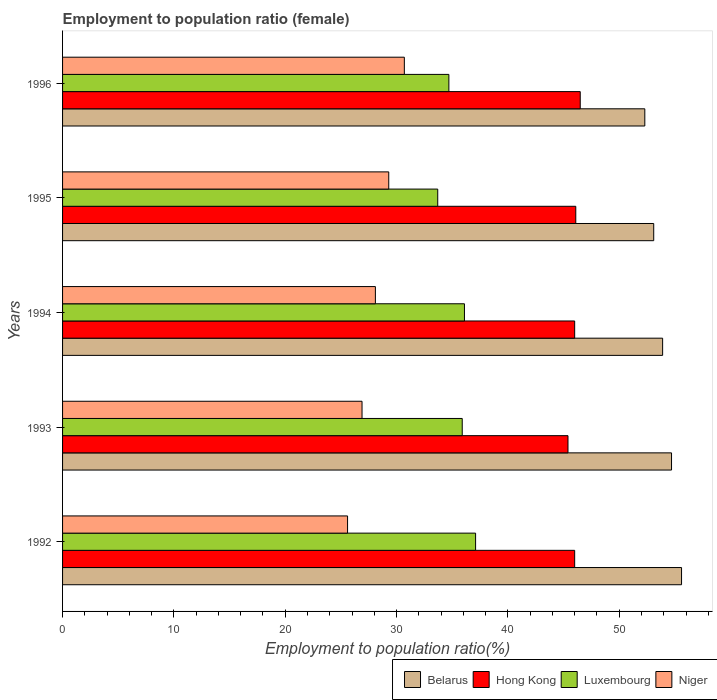Are the number of bars on each tick of the Y-axis equal?
Your answer should be compact. Yes. How many bars are there on the 4th tick from the top?
Offer a terse response. 4. How many bars are there on the 3rd tick from the bottom?
Provide a succinct answer. 4. What is the label of the 5th group of bars from the top?
Provide a succinct answer. 1992. In how many cases, is the number of bars for a given year not equal to the number of legend labels?
Give a very brief answer. 0. What is the employment to population ratio in Niger in 1996?
Your response must be concise. 30.7. Across all years, what is the maximum employment to population ratio in Hong Kong?
Make the answer very short. 46.5. Across all years, what is the minimum employment to population ratio in Belarus?
Make the answer very short. 52.3. What is the total employment to population ratio in Hong Kong in the graph?
Provide a succinct answer. 230. What is the difference between the employment to population ratio in Niger in 1992 and that in 1995?
Your answer should be very brief. -3.7. What is the difference between the employment to population ratio in Hong Kong in 1992 and the employment to population ratio in Belarus in 1996?
Offer a terse response. -6.3. What is the average employment to population ratio in Niger per year?
Provide a short and direct response. 28.12. In the year 1992, what is the difference between the employment to population ratio in Luxembourg and employment to population ratio in Belarus?
Your answer should be compact. -18.5. In how many years, is the employment to population ratio in Niger greater than 30 %?
Ensure brevity in your answer.  1. What is the ratio of the employment to population ratio in Luxembourg in 1993 to that in 1996?
Provide a short and direct response. 1.03. Is the difference between the employment to population ratio in Luxembourg in 1994 and 1996 greater than the difference between the employment to population ratio in Belarus in 1994 and 1996?
Provide a succinct answer. No. What is the difference between the highest and the second highest employment to population ratio in Niger?
Provide a short and direct response. 1.4. What is the difference between the highest and the lowest employment to population ratio in Hong Kong?
Ensure brevity in your answer.  1.1. In how many years, is the employment to population ratio in Hong Kong greater than the average employment to population ratio in Hong Kong taken over all years?
Ensure brevity in your answer.  2. Is the sum of the employment to population ratio in Luxembourg in 1992 and 1993 greater than the maximum employment to population ratio in Belarus across all years?
Provide a short and direct response. Yes. Is it the case that in every year, the sum of the employment to population ratio in Hong Kong and employment to population ratio in Luxembourg is greater than the sum of employment to population ratio in Niger and employment to population ratio in Belarus?
Make the answer very short. No. What does the 4th bar from the top in 1995 represents?
Provide a short and direct response. Belarus. What does the 4th bar from the bottom in 1993 represents?
Your answer should be compact. Niger. How many bars are there?
Offer a terse response. 20. How many years are there in the graph?
Ensure brevity in your answer.  5. Are the values on the major ticks of X-axis written in scientific E-notation?
Your response must be concise. No. Does the graph contain grids?
Your answer should be compact. No. How many legend labels are there?
Ensure brevity in your answer.  4. What is the title of the graph?
Make the answer very short. Employment to population ratio (female). Does "Liechtenstein" appear as one of the legend labels in the graph?
Offer a terse response. No. What is the label or title of the Y-axis?
Your answer should be very brief. Years. What is the Employment to population ratio(%) in Belarus in 1992?
Your response must be concise. 55.6. What is the Employment to population ratio(%) in Hong Kong in 1992?
Provide a succinct answer. 46. What is the Employment to population ratio(%) in Luxembourg in 1992?
Your response must be concise. 37.1. What is the Employment to population ratio(%) in Niger in 1992?
Keep it short and to the point. 25.6. What is the Employment to population ratio(%) of Belarus in 1993?
Provide a short and direct response. 54.7. What is the Employment to population ratio(%) of Hong Kong in 1993?
Make the answer very short. 45.4. What is the Employment to population ratio(%) of Luxembourg in 1993?
Keep it short and to the point. 35.9. What is the Employment to population ratio(%) in Niger in 1993?
Your answer should be very brief. 26.9. What is the Employment to population ratio(%) in Belarus in 1994?
Provide a short and direct response. 53.9. What is the Employment to population ratio(%) of Luxembourg in 1994?
Provide a short and direct response. 36.1. What is the Employment to population ratio(%) of Niger in 1994?
Your answer should be very brief. 28.1. What is the Employment to population ratio(%) in Belarus in 1995?
Provide a short and direct response. 53.1. What is the Employment to population ratio(%) in Hong Kong in 1995?
Your response must be concise. 46.1. What is the Employment to population ratio(%) of Luxembourg in 1995?
Give a very brief answer. 33.7. What is the Employment to population ratio(%) in Niger in 1995?
Offer a very short reply. 29.3. What is the Employment to population ratio(%) in Belarus in 1996?
Your response must be concise. 52.3. What is the Employment to population ratio(%) in Hong Kong in 1996?
Offer a very short reply. 46.5. What is the Employment to population ratio(%) of Luxembourg in 1996?
Provide a short and direct response. 34.7. What is the Employment to population ratio(%) in Niger in 1996?
Ensure brevity in your answer.  30.7. Across all years, what is the maximum Employment to population ratio(%) of Belarus?
Keep it short and to the point. 55.6. Across all years, what is the maximum Employment to population ratio(%) of Hong Kong?
Your answer should be compact. 46.5. Across all years, what is the maximum Employment to population ratio(%) of Luxembourg?
Provide a succinct answer. 37.1. Across all years, what is the maximum Employment to population ratio(%) of Niger?
Offer a terse response. 30.7. Across all years, what is the minimum Employment to population ratio(%) in Belarus?
Provide a short and direct response. 52.3. Across all years, what is the minimum Employment to population ratio(%) in Hong Kong?
Offer a very short reply. 45.4. Across all years, what is the minimum Employment to population ratio(%) of Luxembourg?
Your response must be concise. 33.7. Across all years, what is the minimum Employment to population ratio(%) of Niger?
Offer a very short reply. 25.6. What is the total Employment to population ratio(%) of Belarus in the graph?
Offer a very short reply. 269.6. What is the total Employment to population ratio(%) of Hong Kong in the graph?
Give a very brief answer. 230. What is the total Employment to population ratio(%) in Luxembourg in the graph?
Make the answer very short. 177.5. What is the total Employment to population ratio(%) in Niger in the graph?
Your answer should be compact. 140.6. What is the difference between the Employment to population ratio(%) in Hong Kong in 1992 and that in 1993?
Provide a short and direct response. 0.6. What is the difference between the Employment to population ratio(%) of Niger in 1992 and that in 1993?
Provide a succinct answer. -1.3. What is the difference between the Employment to population ratio(%) in Belarus in 1992 and that in 1994?
Offer a very short reply. 1.7. What is the difference between the Employment to population ratio(%) in Hong Kong in 1992 and that in 1994?
Ensure brevity in your answer.  0. What is the difference between the Employment to population ratio(%) in Belarus in 1992 and that in 1995?
Provide a succinct answer. 2.5. What is the difference between the Employment to population ratio(%) of Hong Kong in 1992 and that in 1995?
Keep it short and to the point. -0.1. What is the difference between the Employment to population ratio(%) in Niger in 1992 and that in 1995?
Give a very brief answer. -3.7. What is the difference between the Employment to population ratio(%) in Belarus in 1992 and that in 1996?
Provide a short and direct response. 3.3. What is the difference between the Employment to population ratio(%) of Niger in 1992 and that in 1996?
Your response must be concise. -5.1. What is the difference between the Employment to population ratio(%) in Hong Kong in 1993 and that in 1994?
Offer a terse response. -0.6. What is the difference between the Employment to population ratio(%) of Luxembourg in 1993 and that in 1994?
Offer a terse response. -0.2. What is the difference between the Employment to population ratio(%) of Belarus in 1993 and that in 1995?
Keep it short and to the point. 1.6. What is the difference between the Employment to population ratio(%) of Belarus in 1993 and that in 1996?
Provide a short and direct response. 2.4. What is the difference between the Employment to population ratio(%) in Hong Kong in 1993 and that in 1996?
Provide a succinct answer. -1.1. What is the difference between the Employment to population ratio(%) of Luxembourg in 1993 and that in 1996?
Your response must be concise. 1.2. What is the difference between the Employment to population ratio(%) in Niger in 1993 and that in 1996?
Provide a short and direct response. -3.8. What is the difference between the Employment to population ratio(%) of Hong Kong in 1994 and that in 1995?
Keep it short and to the point. -0.1. What is the difference between the Employment to population ratio(%) of Luxembourg in 1994 and that in 1995?
Provide a short and direct response. 2.4. What is the difference between the Employment to population ratio(%) of Luxembourg in 1994 and that in 1996?
Provide a short and direct response. 1.4. What is the difference between the Employment to population ratio(%) of Niger in 1994 and that in 1996?
Ensure brevity in your answer.  -2.6. What is the difference between the Employment to population ratio(%) in Niger in 1995 and that in 1996?
Your response must be concise. -1.4. What is the difference between the Employment to population ratio(%) in Belarus in 1992 and the Employment to population ratio(%) in Luxembourg in 1993?
Your response must be concise. 19.7. What is the difference between the Employment to population ratio(%) in Belarus in 1992 and the Employment to population ratio(%) in Niger in 1993?
Give a very brief answer. 28.7. What is the difference between the Employment to population ratio(%) of Hong Kong in 1992 and the Employment to population ratio(%) of Luxembourg in 1993?
Ensure brevity in your answer.  10.1. What is the difference between the Employment to population ratio(%) in Luxembourg in 1992 and the Employment to population ratio(%) in Niger in 1994?
Offer a terse response. 9. What is the difference between the Employment to population ratio(%) in Belarus in 1992 and the Employment to population ratio(%) in Hong Kong in 1995?
Offer a very short reply. 9.5. What is the difference between the Employment to population ratio(%) of Belarus in 1992 and the Employment to population ratio(%) of Luxembourg in 1995?
Ensure brevity in your answer.  21.9. What is the difference between the Employment to population ratio(%) of Belarus in 1992 and the Employment to population ratio(%) of Niger in 1995?
Ensure brevity in your answer.  26.3. What is the difference between the Employment to population ratio(%) in Hong Kong in 1992 and the Employment to population ratio(%) in Luxembourg in 1995?
Provide a short and direct response. 12.3. What is the difference between the Employment to population ratio(%) in Hong Kong in 1992 and the Employment to population ratio(%) in Niger in 1995?
Ensure brevity in your answer.  16.7. What is the difference between the Employment to population ratio(%) of Belarus in 1992 and the Employment to population ratio(%) of Hong Kong in 1996?
Your response must be concise. 9.1. What is the difference between the Employment to population ratio(%) of Belarus in 1992 and the Employment to population ratio(%) of Luxembourg in 1996?
Ensure brevity in your answer.  20.9. What is the difference between the Employment to population ratio(%) in Belarus in 1992 and the Employment to population ratio(%) in Niger in 1996?
Make the answer very short. 24.9. What is the difference between the Employment to population ratio(%) of Hong Kong in 1992 and the Employment to population ratio(%) of Luxembourg in 1996?
Ensure brevity in your answer.  11.3. What is the difference between the Employment to population ratio(%) in Luxembourg in 1992 and the Employment to population ratio(%) in Niger in 1996?
Make the answer very short. 6.4. What is the difference between the Employment to population ratio(%) in Belarus in 1993 and the Employment to population ratio(%) in Hong Kong in 1994?
Provide a succinct answer. 8.7. What is the difference between the Employment to population ratio(%) in Belarus in 1993 and the Employment to population ratio(%) in Luxembourg in 1994?
Your answer should be compact. 18.6. What is the difference between the Employment to population ratio(%) in Belarus in 1993 and the Employment to population ratio(%) in Niger in 1994?
Keep it short and to the point. 26.6. What is the difference between the Employment to population ratio(%) in Hong Kong in 1993 and the Employment to population ratio(%) in Luxembourg in 1994?
Make the answer very short. 9.3. What is the difference between the Employment to population ratio(%) of Belarus in 1993 and the Employment to population ratio(%) of Niger in 1995?
Provide a short and direct response. 25.4. What is the difference between the Employment to population ratio(%) of Hong Kong in 1993 and the Employment to population ratio(%) of Luxembourg in 1995?
Provide a succinct answer. 11.7. What is the difference between the Employment to population ratio(%) in Luxembourg in 1993 and the Employment to population ratio(%) in Niger in 1995?
Make the answer very short. 6.6. What is the difference between the Employment to population ratio(%) of Belarus in 1993 and the Employment to population ratio(%) of Luxembourg in 1996?
Offer a terse response. 20. What is the difference between the Employment to population ratio(%) of Hong Kong in 1993 and the Employment to population ratio(%) of Luxembourg in 1996?
Provide a succinct answer. 10.7. What is the difference between the Employment to population ratio(%) in Luxembourg in 1993 and the Employment to population ratio(%) in Niger in 1996?
Your response must be concise. 5.2. What is the difference between the Employment to population ratio(%) in Belarus in 1994 and the Employment to population ratio(%) in Luxembourg in 1995?
Offer a terse response. 20.2. What is the difference between the Employment to population ratio(%) in Belarus in 1994 and the Employment to population ratio(%) in Niger in 1995?
Your answer should be compact. 24.6. What is the difference between the Employment to population ratio(%) of Hong Kong in 1994 and the Employment to population ratio(%) of Niger in 1995?
Make the answer very short. 16.7. What is the difference between the Employment to population ratio(%) in Belarus in 1994 and the Employment to population ratio(%) in Hong Kong in 1996?
Give a very brief answer. 7.4. What is the difference between the Employment to population ratio(%) in Belarus in 1994 and the Employment to population ratio(%) in Luxembourg in 1996?
Provide a short and direct response. 19.2. What is the difference between the Employment to population ratio(%) of Belarus in 1994 and the Employment to population ratio(%) of Niger in 1996?
Your answer should be compact. 23.2. What is the difference between the Employment to population ratio(%) of Hong Kong in 1994 and the Employment to population ratio(%) of Luxembourg in 1996?
Keep it short and to the point. 11.3. What is the difference between the Employment to population ratio(%) of Belarus in 1995 and the Employment to population ratio(%) of Luxembourg in 1996?
Your response must be concise. 18.4. What is the difference between the Employment to population ratio(%) in Belarus in 1995 and the Employment to population ratio(%) in Niger in 1996?
Make the answer very short. 22.4. What is the difference between the Employment to population ratio(%) of Hong Kong in 1995 and the Employment to population ratio(%) of Luxembourg in 1996?
Keep it short and to the point. 11.4. What is the difference between the Employment to population ratio(%) in Hong Kong in 1995 and the Employment to population ratio(%) in Niger in 1996?
Give a very brief answer. 15.4. What is the average Employment to population ratio(%) in Belarus per year?
Make the answer very short. 53.92. What is the average Employment to population ratio(%) in Hong Kong per year?
Offer a very short reply. 46. What is the average Employment to population ratio(%) in Luxembourg per year?
Ensure brevity in your answer.  35.5. What is the average Employment to population ratio(%) in Niger per year?
Provide a short and direct response. 28.12. In the year 1992, what is the difference between the Employment to population ratio(%) in Belarus and Employment to population ratio(%) in Luxembourg?
Make the answer very short. 18.5. In the year 1992, what is the difference between the Employment to population ratio(%) of Hong Kong and Employment to population ratio(%) of Niger?
Your response must be concise. 20.4. In the year 1993, what is the difference between the Employment to population ratio(%) in Belarus and Employment to population ratio(%) in Hong Kong?
Your answer should be very brief. 9.3. In the year 1993, what is the difference between the Employment to population ratio(%) of Belarus and Employment to population ratio(%) of Niger?
Offer a terse response. 27.8. In the year 1993, what is the difference between the Employment to population ratio(%) of Luxembourg and Employment to population ratio(%) of Niger?
Your answer should be very brief. 9. In the year 1994, what is the difference between the Employment to population ratio(%) of Belarus and Employment to population ratio(%) of Niger?
Your answer should be compact. 25.8. In the year 1994, what is the difference between the Employment to population ratio(%) in Hong Kong and Employment to population ratio(%) in Niger?
Your response must be concise. 17.9. In the year 1994, what is the difference between the Employment to population ratio(%) of Luxembourg and Employment to population ratio(%) of Niger?
Provide a succinct answer. 8. In the year 1995, what is the difference between the Employment to population ratio(%) in Belarus and Employment to population ratio(%) in Niger?
Your answer should be compact. 23.8. In the year 1995, what is the difference between the Employment to population ratio(%) in Hong Kong and Employment to population ratio(%) in Luxembourg?
Your response must be concise. 12.4. In the year 1995, what is the difference between the Employment to population ratio(%) of Hong Kong and Employment to population ratio(%) of Niger?
Keep it short and to the point. 16.8. In the year 1995, what is the difference between the Employment to population ratio(%) of Luxembourg and Employment to population ratio(%) of Niger?
Your answer should be very brief. 4.4. In the year 1996, what is the difference between the Employment to population ratio(%) in Belarus and Employment to population ratio(%) in Hong Kong?
Your answer should be very brief. 5.8. In the year 1996, what is the difference between the Employment to population ratio(%) of Belarus and Employment to population ratio(%) of Niger?
Ensure brevity in your answer.  21.6. In the year 1996, what is the difference between the Employment to population ratio(%) in Hong Kong and Employment to population ratio(%) in Luxembourg?
Your response must be concise. 11.8. In the year 1996, what is the difference between the Employment to population ratio(%) in Hong Kong and Employment to population ratio(%) in Niger?
Offer a very short reply. 15.8. In the year 1996, what is the difference between the Employment to population ratio(%) in Luxembourg and Employment to population ratio(%) in Niger?
Keep it short and to the point. 4. What is the ratio of the Employment to population ratio(%) of Belarus in 1992 to that in 1993?
Provide a short and direct response. 1.02. What is the ratio of the Employment to population ratio(%) in Hong Kong in 1992 to that in 1993?
Ensure brevity in your answer.  1.01. What is the ratio of the Employment to population ratio(%) in Luxembourg in 1992 to that in 1993?
Keep it short and to the point. 1.03. What is the ratio of the Employment to population ratio(%) of Niger in 1992 to that in 1993?
Your response must be concise. 0.95. What is the ratio of the Employment to population ratio(%) in Belarus in 1992 to that in 1994?
Keep it short and to the point. 1.03. What is the ratio of the Employment to population ratio(%) in Hong Kong in 1992 to that in 1994?
Provide a succinct answer. 1. What is the ratio of the Employment to population ratio(%) in Luxembourg in 1992 to that in 1994?
Provide a succinct answer. 1.03. What is the ratio of the Employment to population ratio(%) of Niger in 1992 to that in 1994?
Offer a terse response. 0.91. What is the ratio of the Employment to population ratio(%) in Belarus in 1992 to that in 1995?
Your response must be concise. 1.05. What is the ratio of the Employment to population ratio(%) in Hong Kong in 1992 to that in 1995?
Provide a succinct answer. 1. What is the ratio of the Employment to population ratio(%) of Luxembourg in 1992 to that in 1995?
Provide a short and direct response. 1.1. What is the ratio of the Employment to population ratio(%) of Niger in 1992 to that in 1995?
Provide a succinct answer. 0.87. What is the ratio of the Employment to population ratio(%) of Belarus in 1992 to that in 1996?
Offer a terse response. 1.06. What is the ratio of the Employment to population ratio(%) in Hong Kong in 1992 to that in 1996?
Make the answer very short. 0.99. What is the ratio of the Employment to population ratio(%) of Luxembourg in 1992 to that in 1996?
Provide a short and direct response. 1.07. What is the ratio of the Employment to population ratio(%) in Niger in 1992 to that in 1996?
Make the answer very short. 0.83. What is the ratio of the Employment to population ratio(%) of Belarus in 1993 to that in 1994?
Provide a succinct answer. 1.01. What is the ratio of the Employment to population ratio(%) in Hong Kong in 1993 to that in 1994?
Your answer should be very brief. 0.99. What is the ratio of the Employment to population ratio(%) of Niger in 1993 to that in 1994?
Your answer should be compact. 0.96. What is the ratio of the Employment to population ratio(%) of Belarus in 1993 to that in 1995?
Your answer should be compact. 1.03. What is the ratio of the Employment to population ratio(%) of Hong Kong in 1993 to that in 1995?
Give a very brief answer. 0.98. What is the ratio of the Employment to population ratio(%) of Luxembourg in 1993 to that in 1995?
Your response must be concise. 1.07. What is the ratio of the Employment to population ratio(%) in Niger in 1993 to that in 1995?
Offer a very short reply. 0.92. What is the ratio of the Employment to population ratio(%) of Belarus in 1993 to that in 1996?
Your answer should be compact. 1.05. What is the ratio of the Employment to population ratio(%) in Hong Kong in 1993 to that in 1996?
Provide a short and direct response. 0.98. What is the ratio of the Employment to population ratio(%) in Luxembourg in 1993 to that in 1996?
Offer a terse response. 1.03. What is the ratio of the Employment to population ratio(%) of Niger in 1993 to that in 1996?
Offer a very short reply. 0.88. What is the ratio of the Employment to population ratio(%) of Belarus in 1994 to that in 1995?
Your answer should be compact. 1.02. What is the ratio of the Employment to population ratio(%) in Luxembourg in 1994 to that in 1995?
Give a very brief answer. 1.07. What is the ratio of the Employment to population ratio(%) in Belarus in 1994 to that in 1996?
Offer a very short reply. 1.03. What is the ratio of the Employment to population ratio(%) in Hong Kong in 1994 to that in 1996?
Offer a very short reply. 0.99. What is the ratio of the Employment to population ratio(%) of Luxembourg in 1994 to that in 1996?
Your response must be concise. 1.04. What is the ratio of the Employment to population ratio(%) in Niger in 1994 to that in 1996?
Your answer should be very brief. 0.92. What is the ratio of the Employment to population ratio(%) in Belarus in 1995 to that in 1996?
Ensure brevity in your answer.  1.02. What is the ratio of the Employment to population ratio(%) in Hong Kong in 1995 to that in 1996?
Make the answer very short. 0.99. What is the ratio of the Employment to population ratio(%) in Luxembourg in 1995 to that in 1996?
Ensure brevity in your answer.  0.97. What is the ratio of the Employment to population ratio(%) of Niger in 1995 to that in 1996?
Provide a succinct answer. 0.95. What is the difference between the highest and the second highest Employment to population ratio(%) of Belarus?
Offer a very short reply. 0.9. What is the difference between the highest and the second highest Employment to population ratio(%) in Hong Kong?
Offer a terse response. 0.4. What is the difference between the highest and the lowest Employment to population ratio(%) of Hong Kong?
Provide a short and direct response. 1.1. What is the difference between the highest and the lowest Employment to population ratio(%) of Luxembourg?
Ensure brevity in your answer.  3.4. 